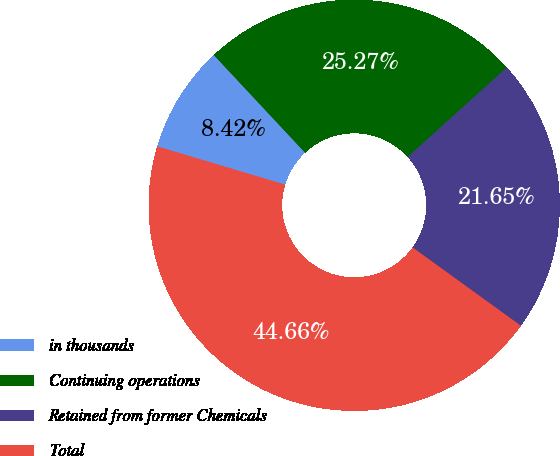<chart> <loc_0><loc_0><loc_500><loc_500><pie_chart><fcel>in thousands<fcel>Continuing operations<fcel>Retained from former Chemicals<fcel>Total<nl><fcel>8.42%<fcel>25.27%<fcel>21.65%<fcel>44.66%<nl></chart> 